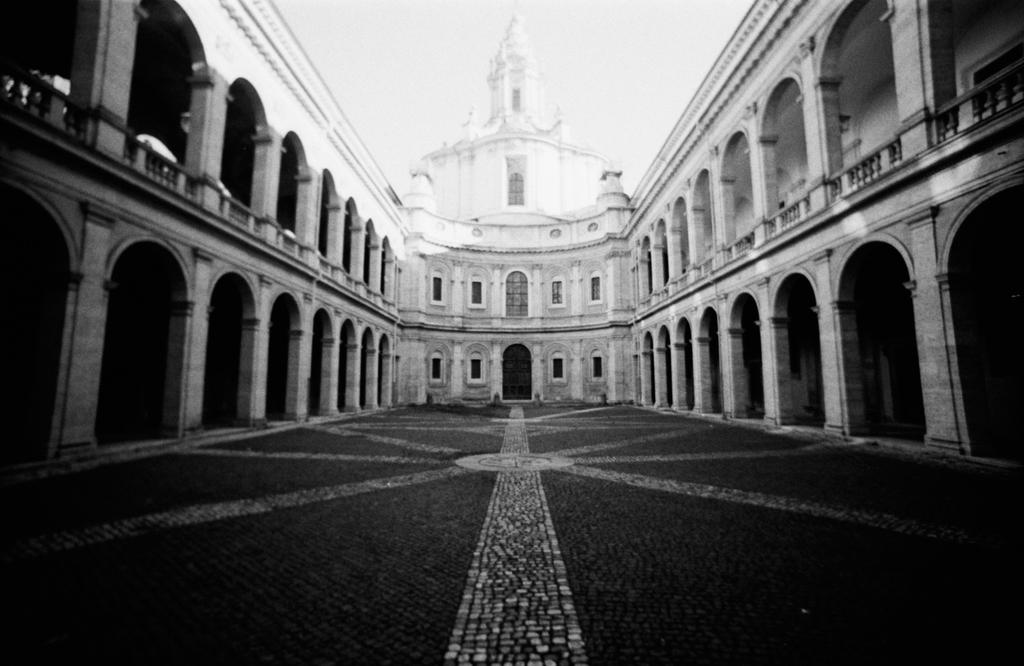What type of structure is present in the image? There is a building in the image. What are some features of the building? The building has windows, pillars, and a door. Is there any indication of a path or walkway in the image? Yes, there is a path in the image. What can be seen in the background of the image? The sky is visible in the background of the image. Can you tell me the name of the organization that issued the receipt in the image? There is no receipt present in the image, so it is not possible to determine the name of any organization. 